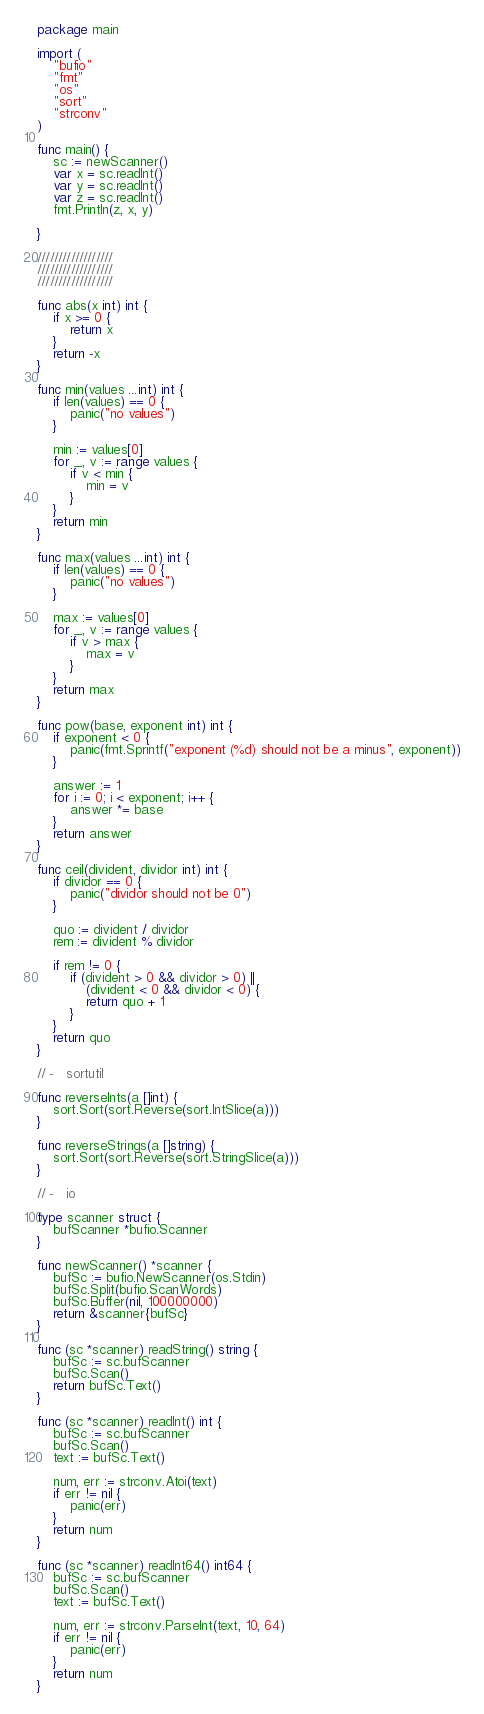<code> <loc_0><loc_0><loc_500><loc_500><_Go_>package main

import (
	"bufio"
	"fmt"
	"os"
	"sort"
	"strconv"
)

func main() {
	sc := newScanner()
	var x = sc.readInt()
	var y = sc.readInt()
	var z = sc.readInt()
	fmt.Println(z, x, y)

}

//////////////////
//////////////////
//////////////////

func abs(x int) int {
	if x >= 0 {
		return x
	}
	return -x
}

func min(values ...int) int {
	if len(values) == 0 {
		panic("no values")
	}

	min := values[0]
	for _, v := range values {
		if v < min {
			min = v
		}
	}
	return min
}

func max(values ...int) int {
	if len(values) == 0 {
		panic("no values")
	}

	max := values[0]
	for _, v := range values {
		if v > max {
			max = v
		}
	}
	return max
}

func pow(base, exponent int) int {
	if exponent < 0 {
		panic(fmt.Sprintf("exponent (%d) should not be a minus", exponent))
	}

	answer := 1
	for i := 0; i < exponent; i++ {
		answer *= base
	}
	return answer
}

func ceil(divident, dividor int) int {
	if dividor == 0 {
		panic("dividor should not be 0")
	}

	quo := divident / dividor
	rem := divident % dividor

	if rem != 0 {
		if (divident > 0 && dividor > 0) ||
			(divident < 0 && dividor < 0) {
			return quo + 1
		}
	}
	return quo
}

// -   sortutil

func reverseInts(a []int) {
	sort.Sort(sort.Reverse(sort.IntSlice(a)))
}

func reverseStrings(a []string) {
	sort.Sort(sort.Reverse(sort.StringSlice(a)))
}

// -   io

type scanner struct {
	bufScanner *bufio.Scanner
}

func newScanner() *scanner {
	bufSc := bufio.NewScanner(os.Stdin)
	bufSc.Split(bufio.ScanWords)
	bufSc.Buffer(nil, 100000000)
	return &scanner{bufSc}
}

func (sc *scanner) readString() string {
	bufSc := sc.bufScanner
	bufSc.Scan()
	return bufSc.Text()
}

func (sc *scanner) readInt() int {
	bufSc := sc.bufScanner
	bufSc.Scan()
	text := bufSc.Text()

	num, err := strconv.Atoi(text)
	if err != nil {
		panic(err)
	}
	return num
}

func (sc *scanner) readInt64() int64 {
	bufSc := sc.bufScanner
	bufSc.Scan()
	text := bufSc.Text()

	num, err := strconv.ParseInt(text, 10, 64)
	if err != nil {
		panic(err)
	}
	return num
}
</code> 